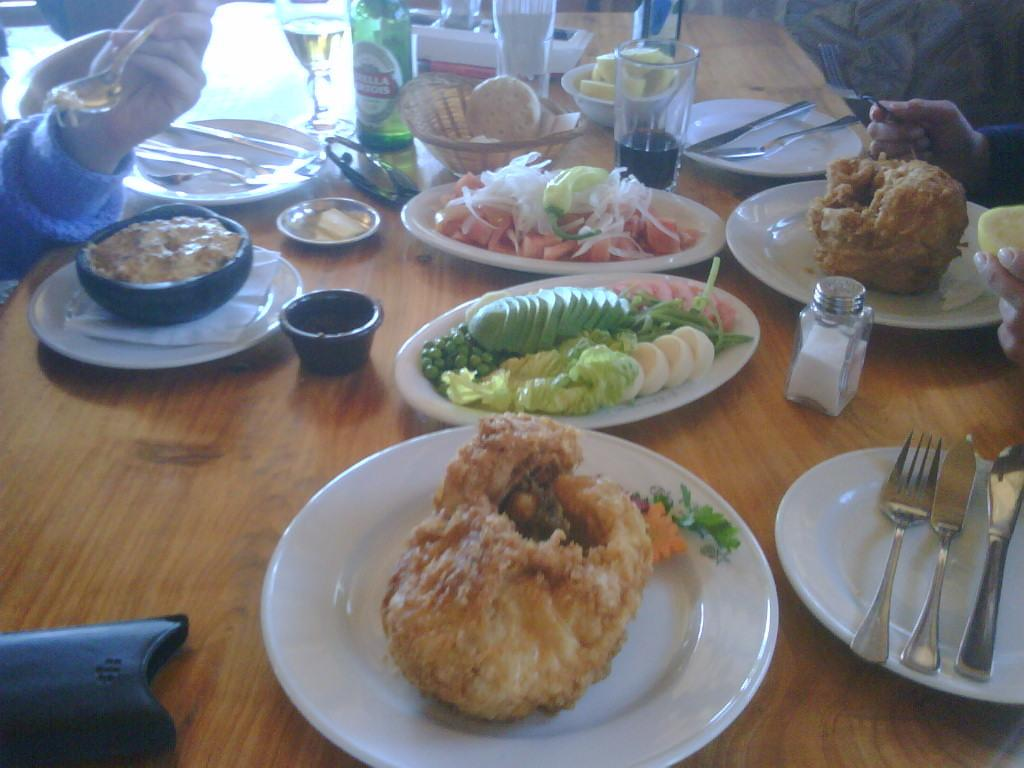What is on the plate in the image? There are food items on the plate in the image. What can be seen on the table in the image? There are glasses, wine bottles, and forks on the table in the image. What other objects are present on the table in the image? There are a few other objects on the table in the image. Are there any people in the image? Yes, there are people beside the table in the image. What type of honey is being served in the club in the image? There is no mention of a club or honey in the image. The image features a table with food items, glasses, wine bottles, forks, and people beside the table. 